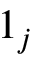<formula> <loc_0><loc_0><loc_500><loc_500>1 _ { j }</formula> 